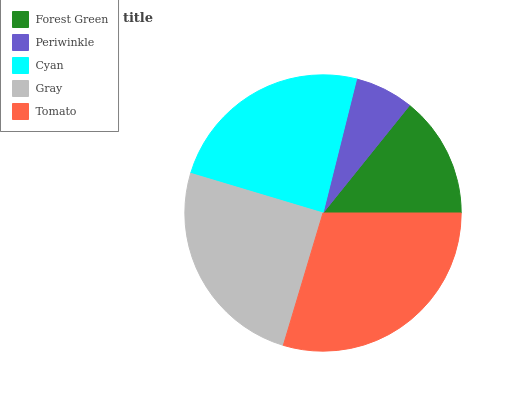Is Periwinkle the minimum?
Answer yes or no. Yes. Is Tomato the maximum?
Answer yes or no. Yes. Is Cyan the minimum?
Answer yes or no. No. Is Cyan the maximum?
Answer yes or no. No. Is Cyan greater than Periwinkle?
Answer yes or no. Yes. Is Periwinkle less than Cyan?
Answer yes or no. Yes. Is Periwinkle greater than Cyan?
Answer yes or no. No. Is Cyan less than Periwinkle?
Answer yes or no. No. Is Cyan the high median?
Answer yes or no. Yes. Is Cyan the low median?
Answer yes or no. Yes. Is Gray the high median?
Answer yes or no. No. Is Periwinkle the low median?
Answer yes or no. No. 